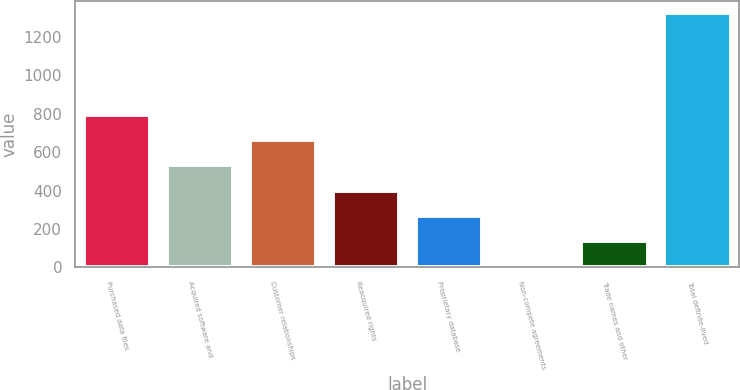Convert chart to OTSL. <chart><loc_0><loc_0><loc_500><loc_500><bar_chart><fcel>Purchased data files<fcel>Acquired software and<fcel>Customer relationships<fcel>Reacquired rights<fcel>Proprietary database<fcel>Non-compete agreements<fcel>Trade names and other<fcel>Total definite-lived<nl><fcel>796.12<fcel>532.28<fcel>664.2<fcel>400.36<fcel>268.44<fcel>4.6<fcel>136.52<fcel>1323.8<nl></chart> 